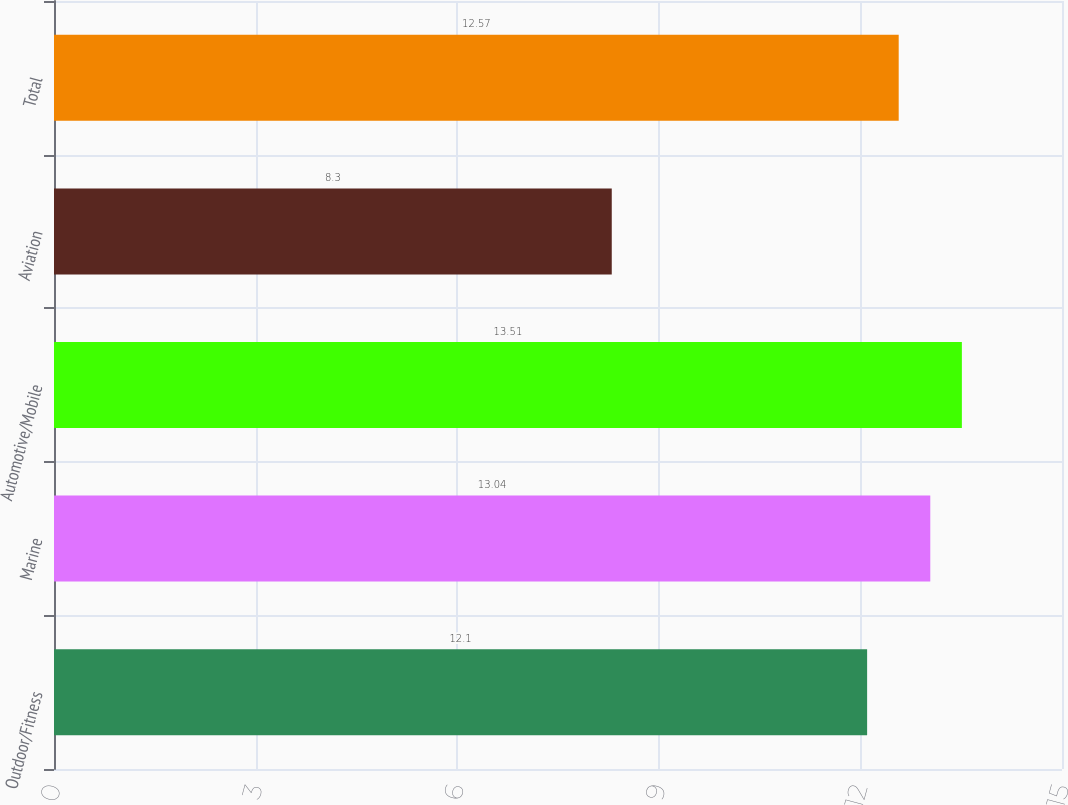Convert chart. <chart><loc_0><loc_0><loc_500><loc_500><bar_chart><fcel>Outdoor/Fitness<fcel>Marine<fcel>Automotive/Mobile<fcel>Aviation<fcel>Total<nl><fcel>12.1<fcel>13.04<fcel>13.51<fcel>8.3<fcel>12.57<nl></chart> 